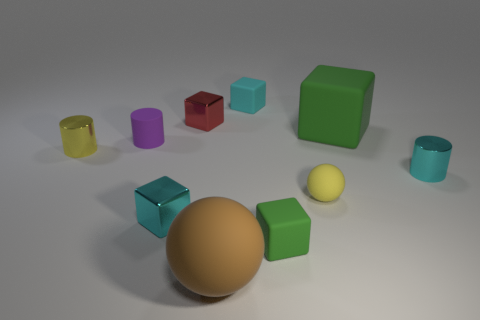Subtract 1 cylinders. How many cylinders are left? 2 Subtract all red cubes. How many cubes are left? 4 Subtract all small green cubes. How many cubes are left? 4 Subtract all blue cubes. Subtract all yellow spheres. How many cubes are left? 5 Subtract all balls. How many objects are left? 8 Add 5 large brown spheres. How many large brown spheres are left? 6 Add 7 yellow rubber things. How many yellow rubber things exist? 8 Subtract 0 blue balls. How many objects are left? 10 Subtract all matte objects. Subtract all small cyan metal things. How many objects are left? 2 